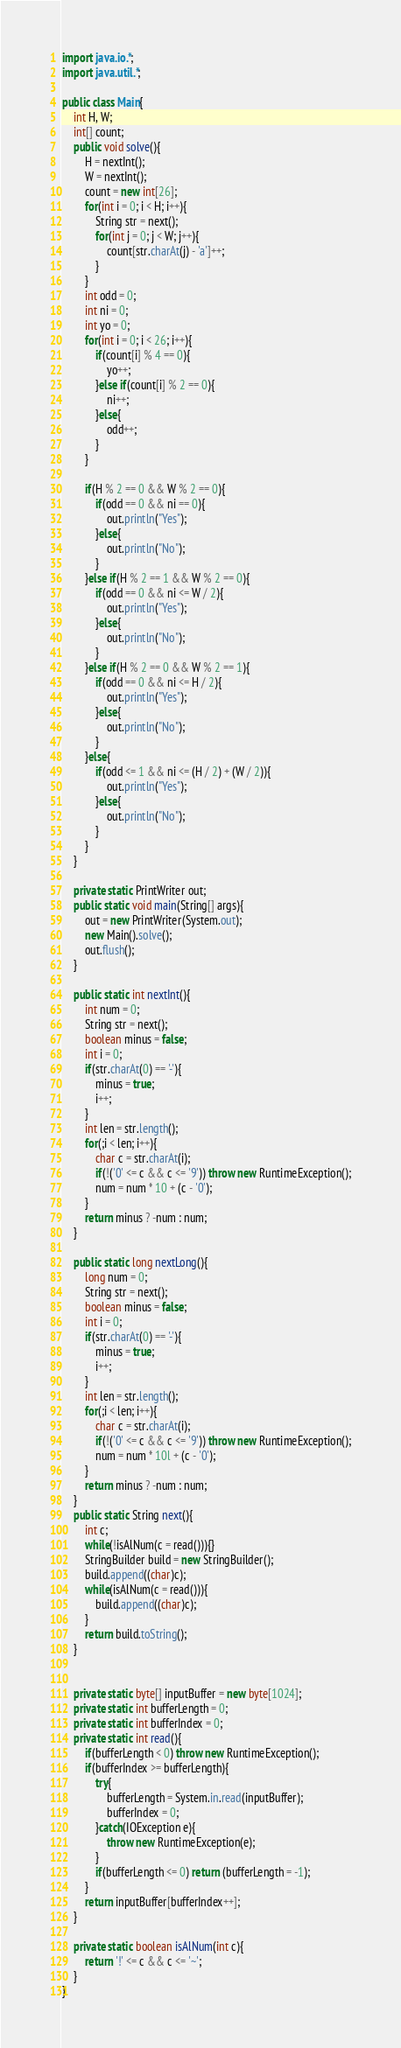Convert code to text. <code><loc_0><loc_0><loc_500><loc_500><_Java_>
import java.io.*;
import java.util.*;
 
public class Main{
	int H, W;
	int[] count;
	public void solve(){
		H = nextInt();
		W = nextInt();
		count = new int[26];
		for(int i = 0; i < H; i++){
			String str = next();
			for(int j = 0; j < W; j++){
				count[str.charAt(j) - 'a']++;
			}
		}
		int odd = 0;
		int ni = 0;
		int yo = 0;
		for(int i = 0; i < 26; i++){
			if(count[i] % 4 == 0){
				yo++;
			}else if(count[i] % 2 == 0){
				ni++;
			}else{
				odd++;
			}
		}
		
		if(H % 2 == 0 && W % 2 == 0){
			if(odd == 0 && ni == 0){
				out.println("Yes");
			}else{
				out.println("No");
			}
		}else if(H % 2 == 1 && W % 2 == 0){
			if(odd == 0 && ni <= W / 2){
				out.println("Yes");
			}else{
				out.println("No");
			}	
		}else if(H % 2 == 0 && W % 2 == 1){
			if(odd == 0 && ni <= H / 2){
				out.println("Yes");
			}else{
				out.println("No");
			}
		}else{
			if(odd <= 1 && ni <= (H / 2) + (W / 2)){
				out.println("Yes");
			}else{
				out.println("No");
			}
		}
	}
	
	private static PrintWriter out;
	public static void main(String[] args){
		out = new PrintWriter(System.out);
		new Main().solve();
		out.flush();
	}
	
	public static int nextInt(){
		int num = 0;
		String str = next();
		boolean minus = false;
		int i = 0;
		if(str.charAt(0) == '-'){
			minus = true;
			i++;
		}
		int len = str.length();
		for(;i < len; i++){
			char c = str.charAt(i);
			if(!('0' <= c && c <= '9')) throw new RuntimeException();
			num = num * 10 + (c - '0');
		}
		return minus ? -num : num;
	}
	
	public static long nextLong(){
		long num = 0;
		String str = next();
		boolean minus = false;
		int i = 0;
		if(str.charAt(0) == '-'){
			minus = true;
			i++;
		}
		int len = str.length();
		for(;i < len; i++){
			char c = str.charAt(i);
			if(!('0' <= c && c <= '9')) throw new RuntimeException();
			num = num * 10l + (c - '0');
		}
		return minus ? -num : num;
	}
	public static String next(){
		int c;
		while(!isAlNum(c = read())){}
		StringBuilder build = new StringBuilder();
		build.append((char)c);
		while(isAlNum(c = read())){
			build.append((char)c);
		}
		return build.toString();
	}
	
	
	private static byte[] inputBuffer = new byte[1024];
	private static int bufferLength = 0;
	private static int bufferIndex = 0;
	private static int read(){
		if(bufferLength < 0) throw new RuntimeException();
		if(bufferIndex >= bufferLength){
			try{
				bufferLength = System.in.read(inputBuffer);
				bufferIndex = 0;
			}catch(IOException e){
				throw new RuntimeException(e);
			}
			if(bufferLength <= 0) return (bufferLength = -1);
		}
		return inputBuffer[bufferIndex++];
	}
	
	private static boolean isAlNum(int c){
		return '!' <= c && c <= '~';
	}
}</code> 